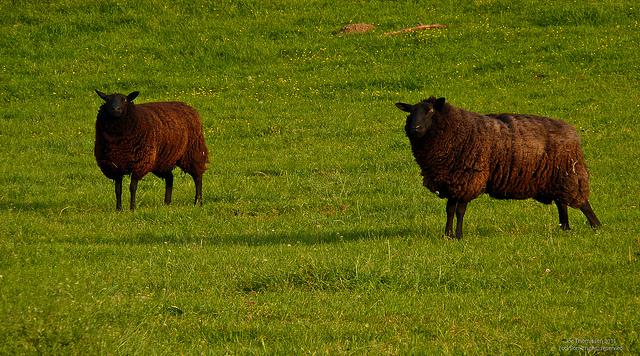Are the sheep sheared?
Concise answer only. No. What color are the sheep?
Be succinct. Brown. How many animals can be seen?
Quick response, please. 2. 